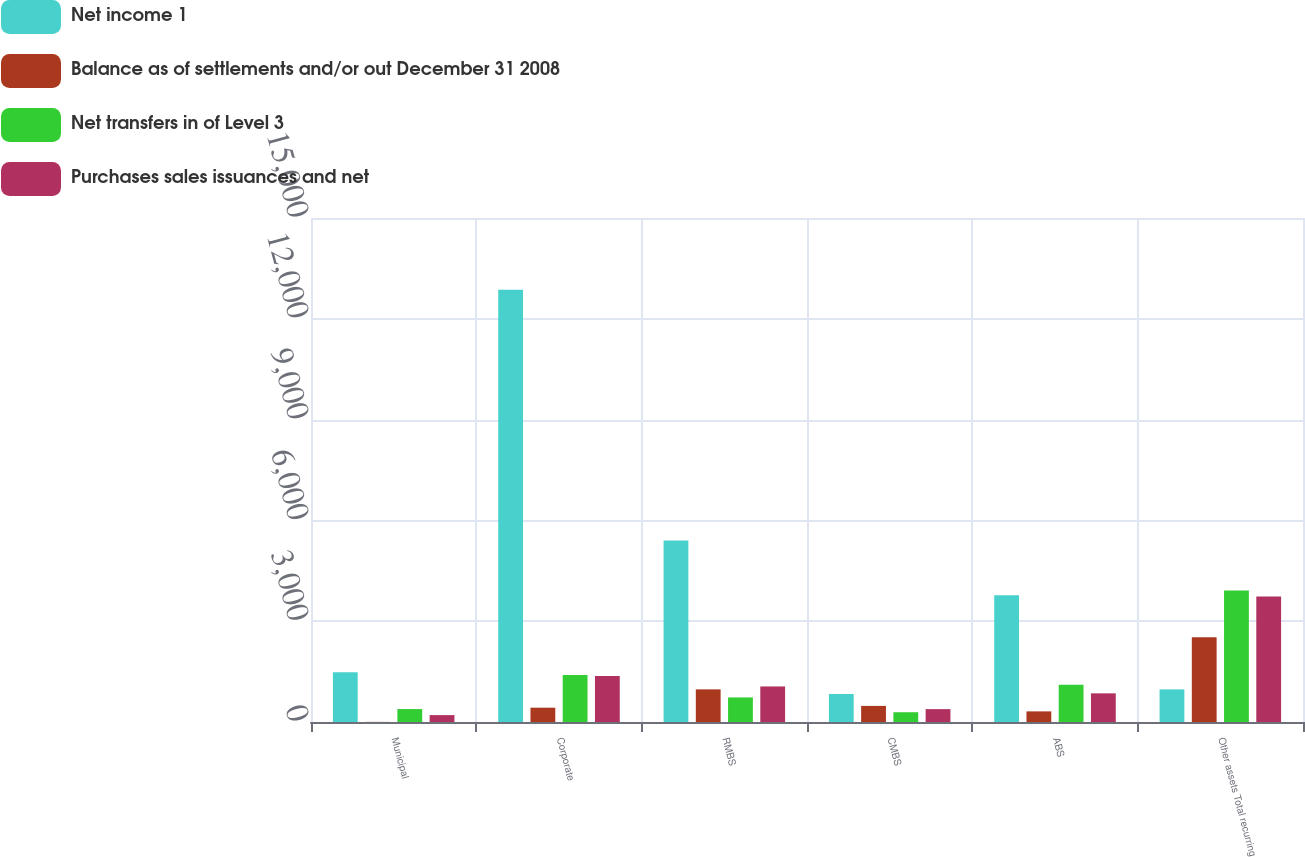Convert chart. <chart><loc_0><loc_0><loc_500><loc_500><stacked_bar_chart><ecel><fcel>Municipal<fcel>Corporate<fcel>RMBS<fcel>CMBS<fcel>ABS<fcel>Other assets Total recurring<nl><fcel>Net income 1<fcel>1477<fcel>12868<fcel>5405<fcel>833<fcel>3769<fcel>971<nl><fcel>Balance as of settlements and/or out December 31 2008<fcel>3<fcel>426<fcel>971<fcel>479<fcel>316<fcel>2525<nl><fcel>Net transfers in of Level 3<fcel>385<fcel>1402<fcel>731<fcel>291<fcel>1106<fcel>3910<nl><fcel>Purchases sales issuances and net<fcel>205<fcel>1371<fcel>1058<fcel>383<fcel>853<fcel>3732<nl></chart> 